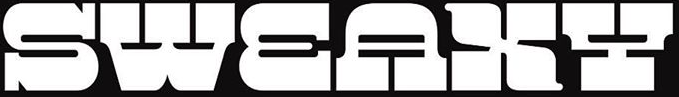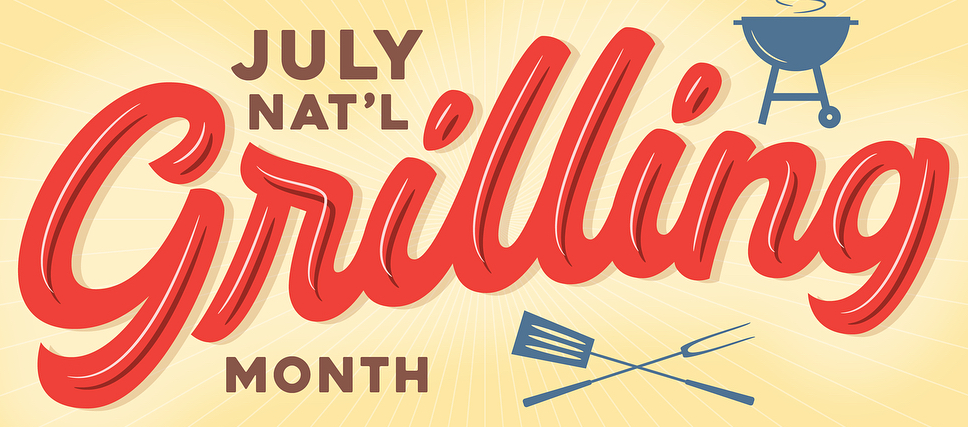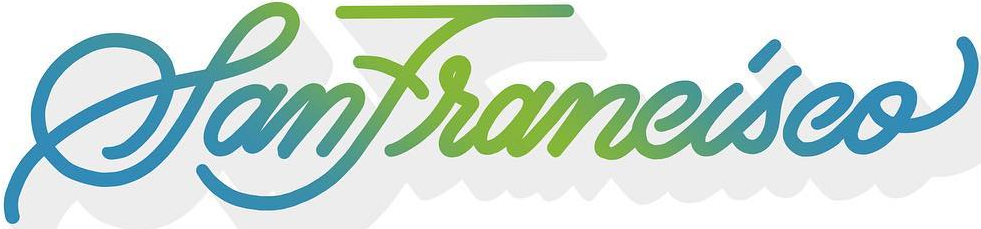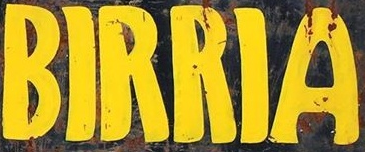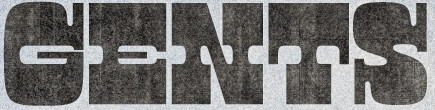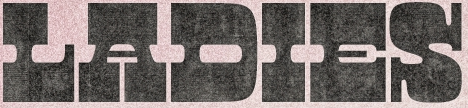Read the text from these images in sequence, separated by a semicolon. SWEAXY; Grilling; SanFrancisco; BIRRIA; GENTS; LADIES 